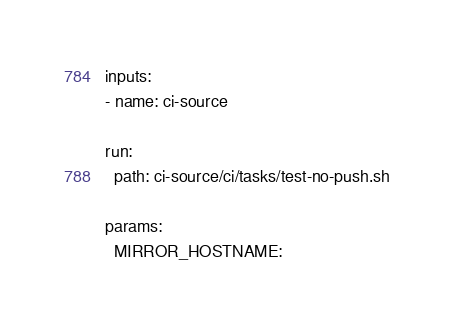<code> <loc_0><loc_0><loc_500><loc_500><_YAML_>inputs:
- name: ci-source

run:
  path: ci-source/ci/tasks/test-no-push.sh

params:
  MIRROR_HOSTNAME:
</code> 